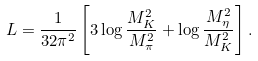Convert formula to latex. <formula><loc_0><loc_0><loc_500><loc_500>L = \frac { 1 } { 3 2 \pi ^ { 2 } } \left [ 3 \log \frac { M _ { K } ^ { 2 } } { M _ { \pi } ^ { 2 } } + \log \frac { M _ { \eta } ^ { 2 } } { M _ { K } ^ { 2 } } \right ] .</formula> 